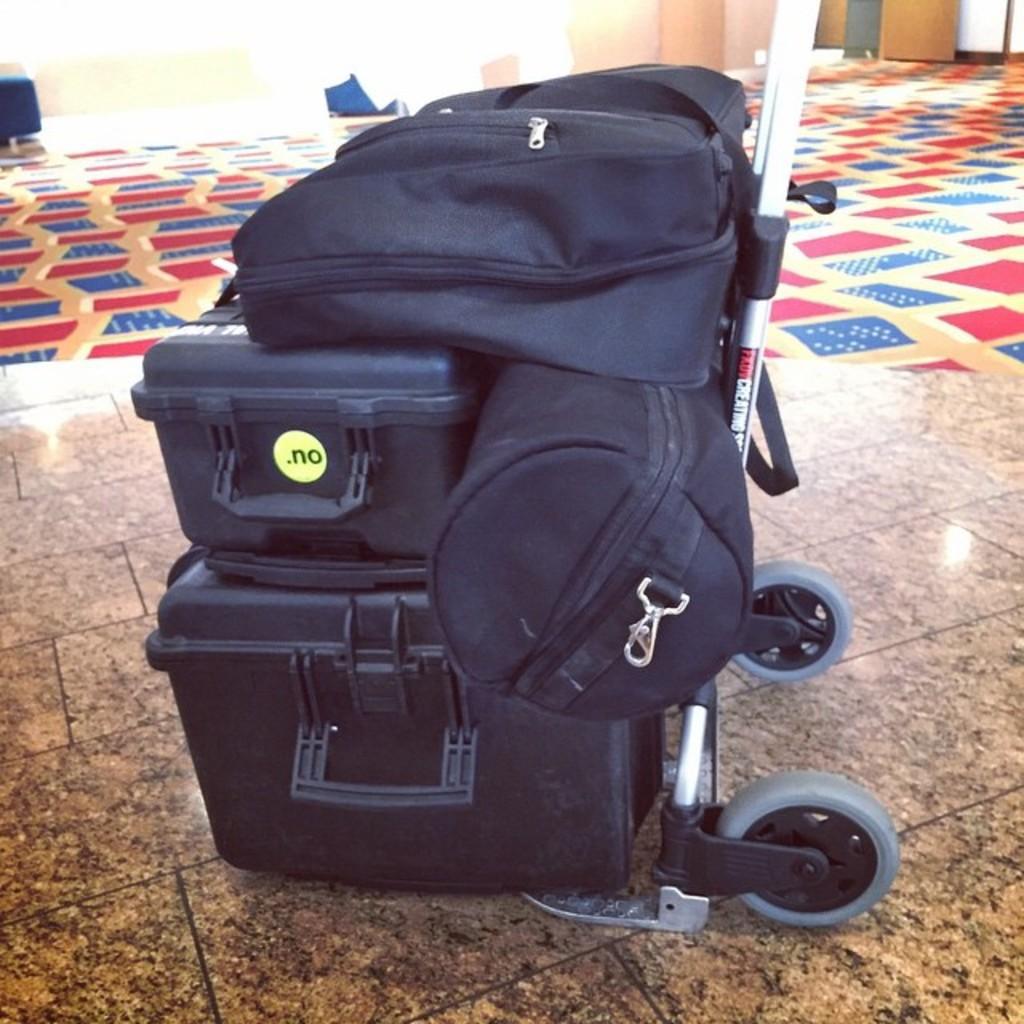In one or two sentences, can you explain what this image depicts? In this image, in the middle there is a bag which is in black color, on that bag there is a black color box kept, in the background there is a red color carpet. 